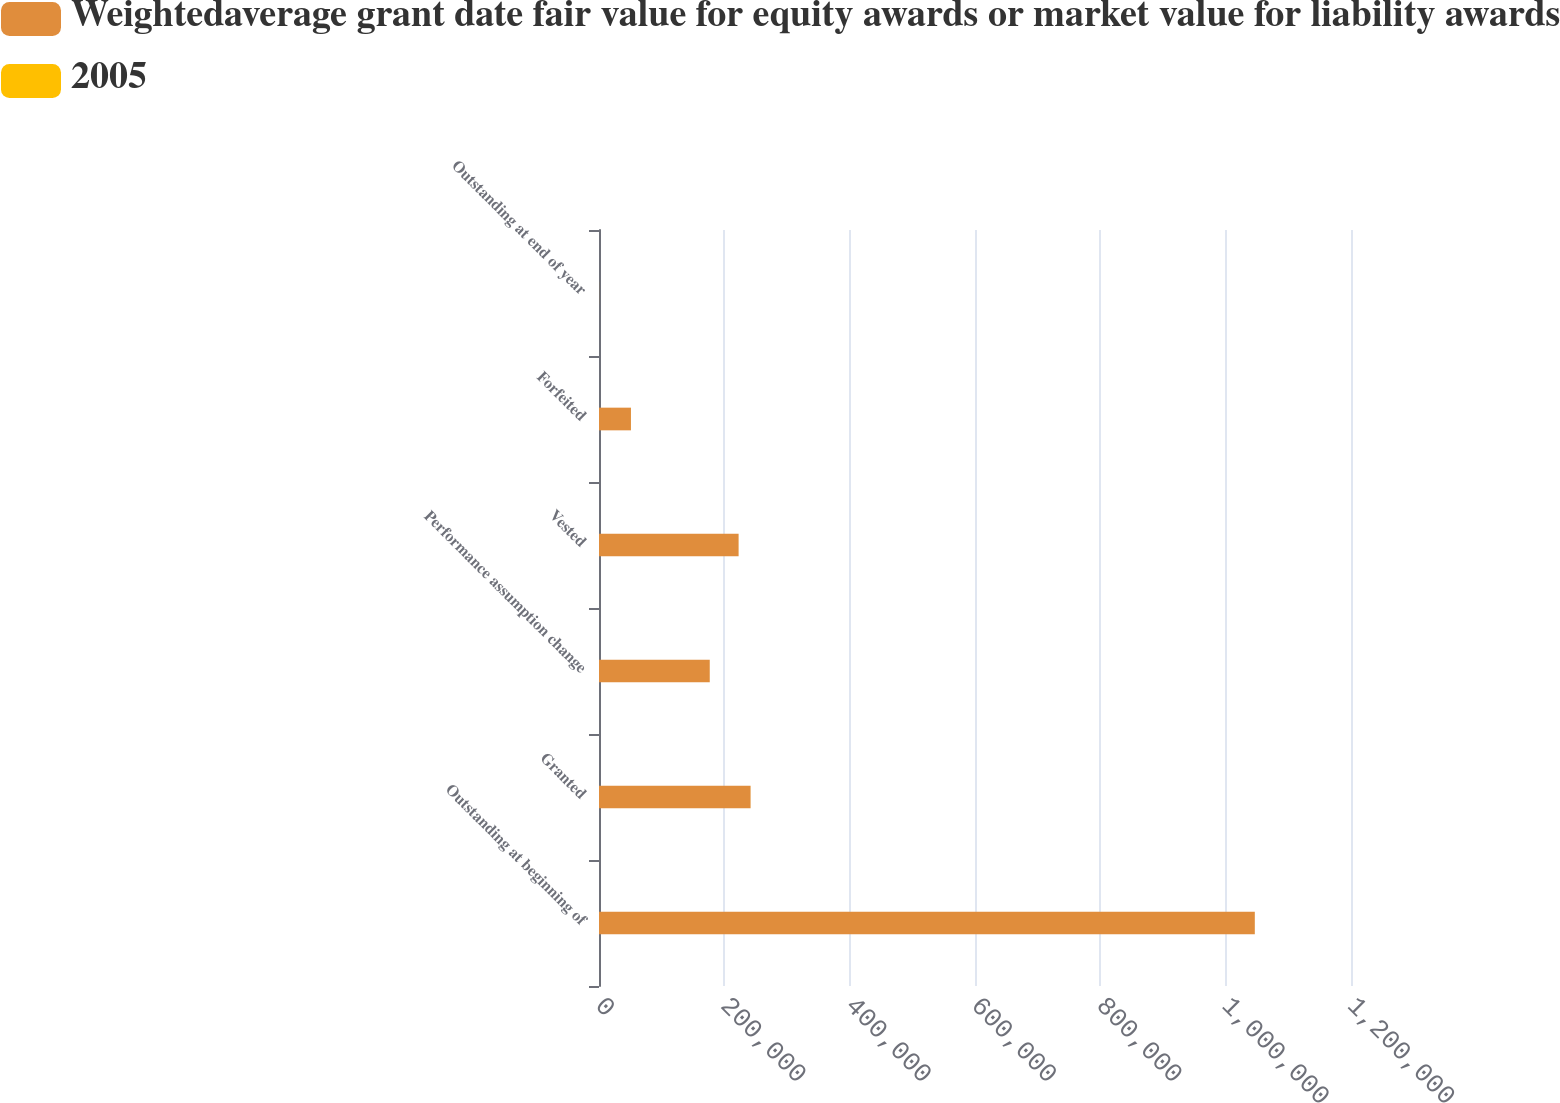Convert chart. <chart><loc_0><loc_0><loc_500><loc_500><stacked_bar_chart><ecel><fcel>Outstanding at beginning of<fcel>Granted<fcel>Performance assumption change<fcel>Vested<fcel>Forfeited<fcel>Outstanding at end of year<nl><fcel>Weightedaverage grant date fair value for equity awards or market value for liability awards<fcel>1.0465e+06<fcel>241887<fcel>176725<fcel>222759<fcel>50985<fcel>57.21<nl><fcel>2005<fcel>47.57<fcel>57.21<fcel>44.42<fcel>55.74<fcel>51.28<fcel>47.01<nl></chart> 